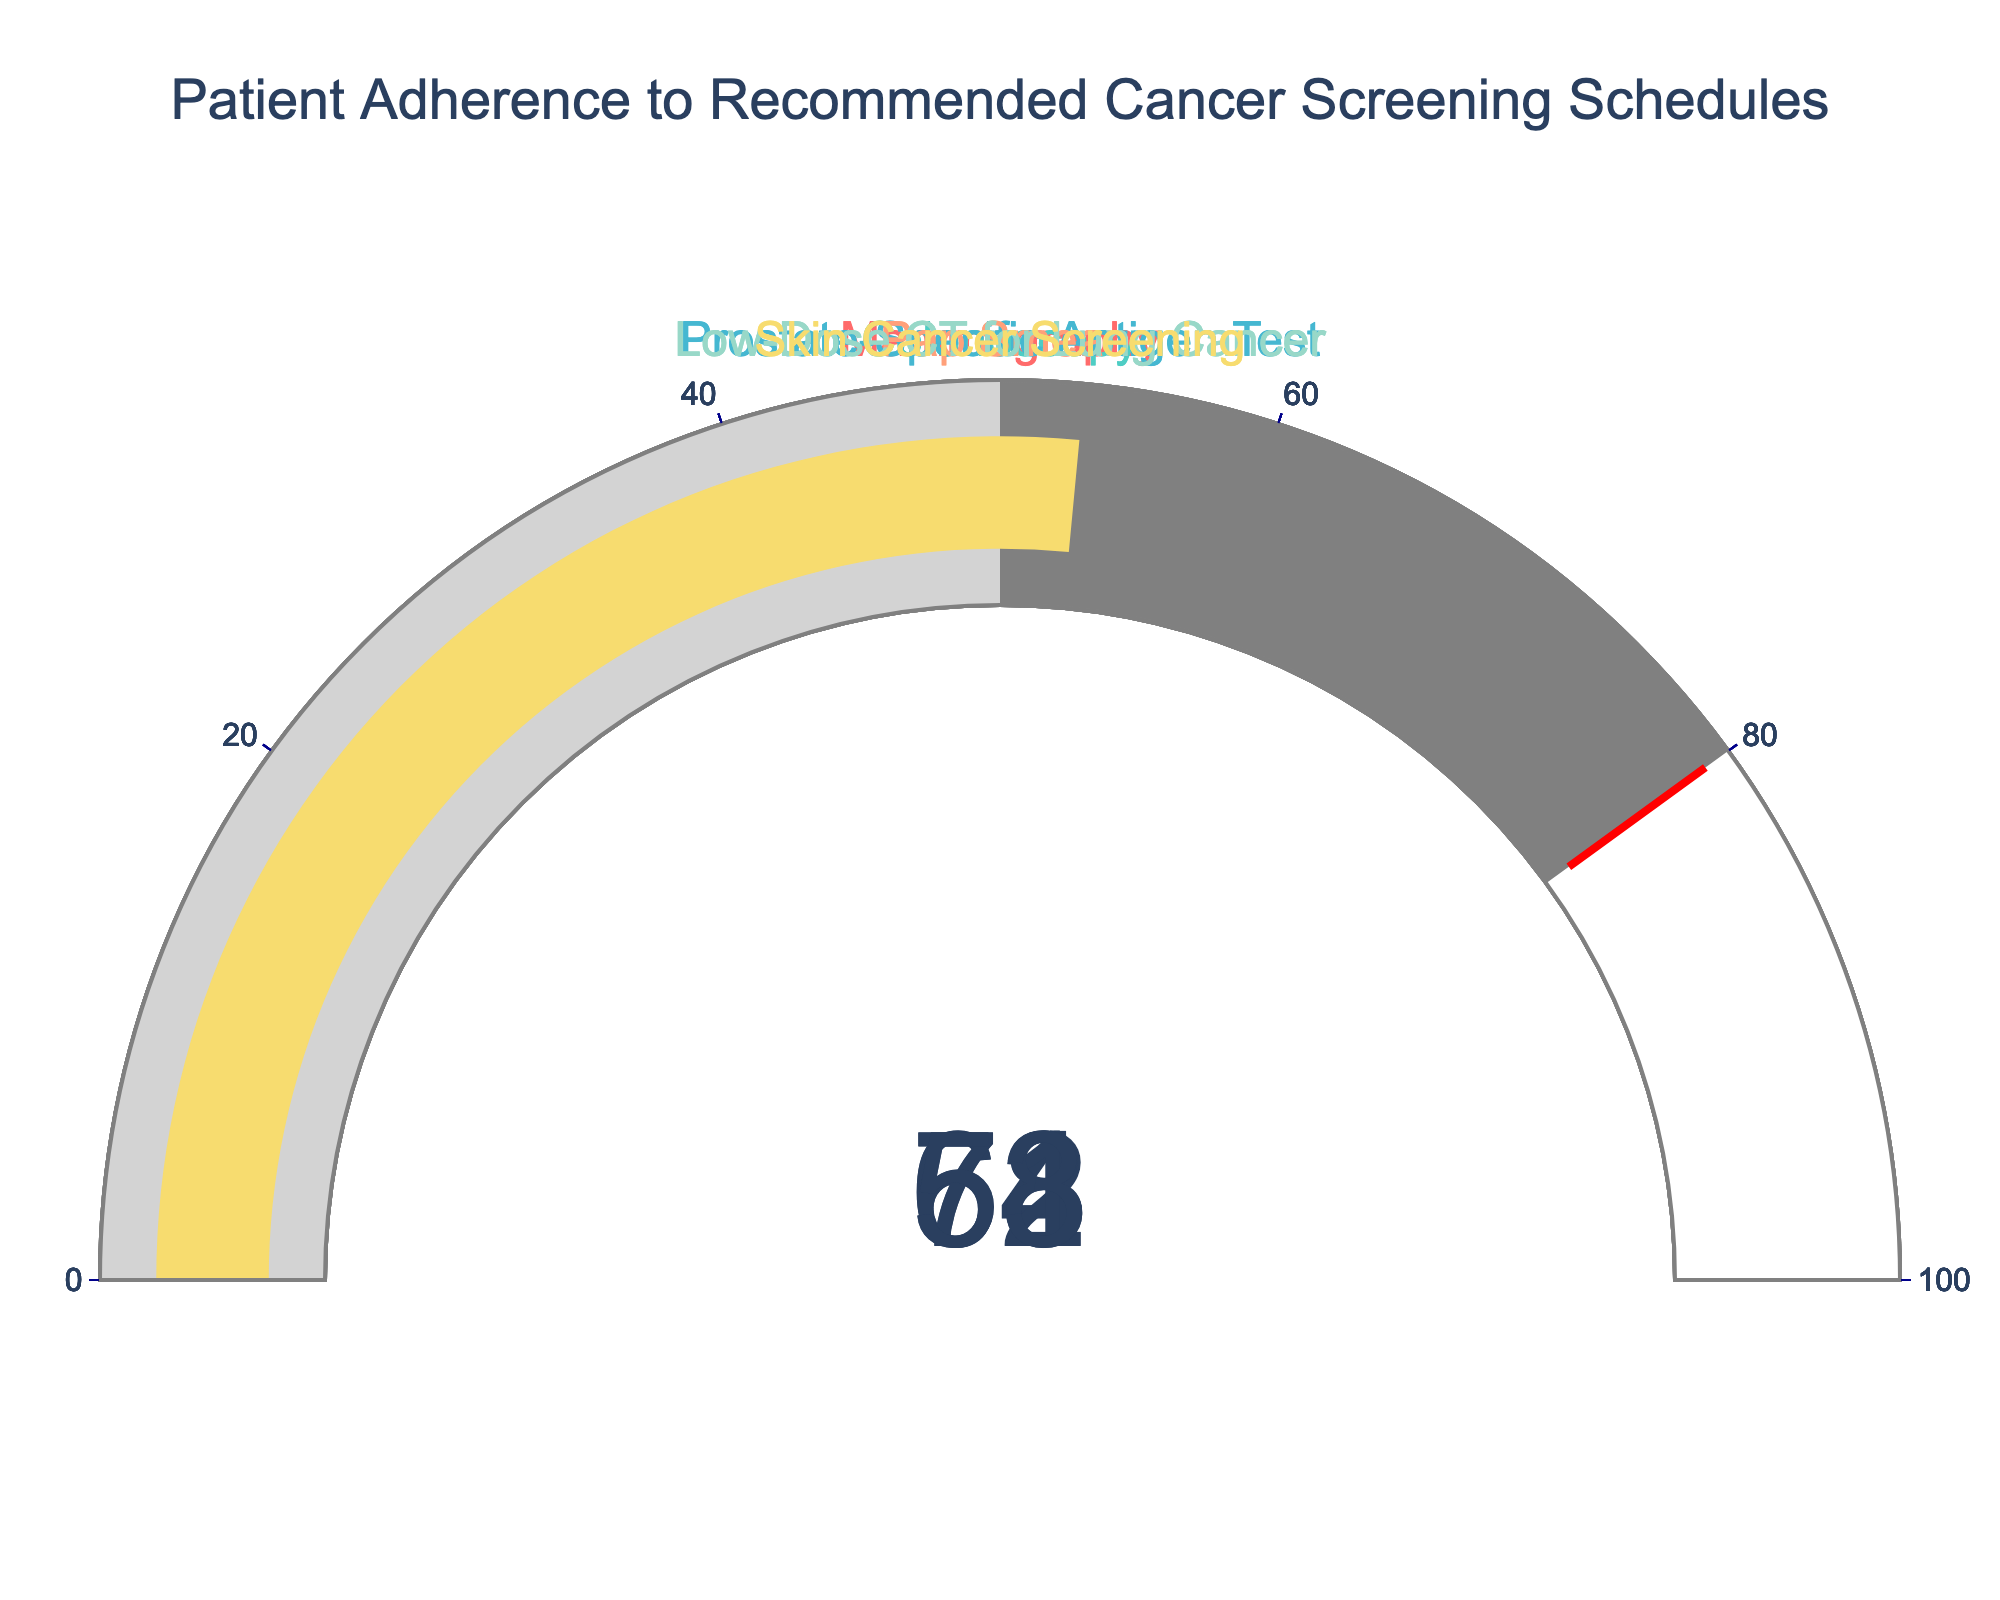What's the adherence percentage for Mammography? Look at the gauge chart corresponding to Mammography to find the value displayed.
Answer: 74% Which screening type has the highest adherence percentage? Compare all the adherence percentages for each screening type and identify the highest one.
Answer: Mammography Which screening type has the lowest adherence percentage? Check all the adherence percentages and find the lowest one amongst the screening types.
Answer: Skin Cancer Screening What is the average adherence percentage for all screening types? Add all the adherence percentages and divide by the total number of screening types: (74 + 68 + 62 + 71 + 58 + 53) / 6 = 386 / 6
Answer: 64.33 How many screening types have adherence percentages above 65%? Count how many screening types have adherence percentages greater than 65: Mammography (74), Colonoscopy (68), Pap Smear (71).
Answer: 3 By how much does the adherence percentage for the Pap Smear exceed that for the Prostate-Specific Antigen Test? Subtract the adherence percentage of Prostate-Specific Antigen Test (62) from Pap Smear (71): 71 - 62 = 9.
Answer: 9 Which categories fall into the "gray" range (50-80%) on their gauges? Identify categories with adherence percentages between 50 and 80: Mammography (74), Colonoscopy (68), Prostate-Specific Antigen Test (62), Pap Smear (71), Low-Dose CT for Lung Cancer (58), Skin Cancer Screening (53).
Answer: All categories Is the adherence percentage for Low-Dose CT for Lung Cancer closer to Skin Cancer Screening or Colonoscopy? Calculate the differences: 58 - 53 = 5, 68 - 58 = 10. The closer number is the smallest difference.
Answer: Skin Cancer Screening 